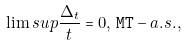<formula> <loc_0><loc_0><loc_500><loc_500>\lim s u p \frac { \Delta _ { t } } { t } = 0 , \, { \tt M T } - a . s . ,</formula> 